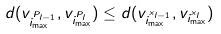<formula> <loc_0><loc_0><loc_500><loc_500>d ( v _ { i _ { \max } ^ { P _ { l - 1 } } } , v _ { i _ { \max } ^ { P _ { l } } } ) \leq d ( v _ { i _ { \max } ^ { x _ { l - 1 } } } , v _ { i _ { \max } ^ { x _ { l } } } )</formula> 